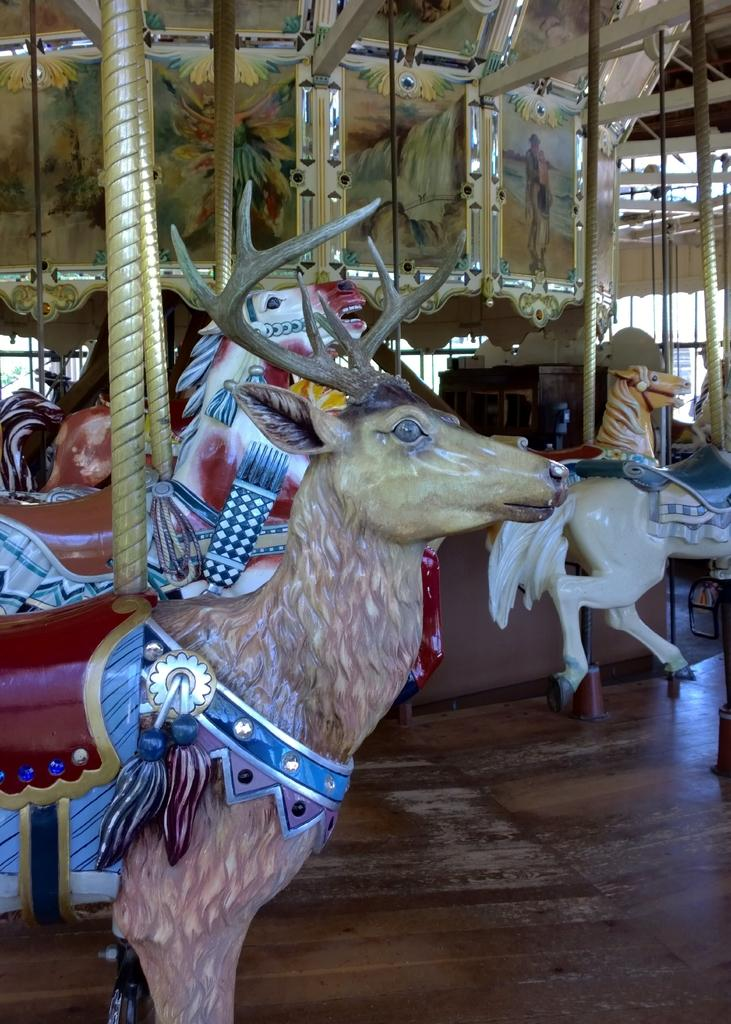What type of attractions can be seen in the image? There are exhibition rides in the image. What are the rods used for in the image? The purpose of the rods is not specified in the facts, but they are visible in the image. What type of visuals are present in the image? There are pictures in the image. What type of flooring is present in the image? There is a wooden floor in the image. What else can be seen in the image besides the rides, rods, and pictures? There are objects in the image. What type of joke is being told by the mine in the image? There is no mine present in the image. 